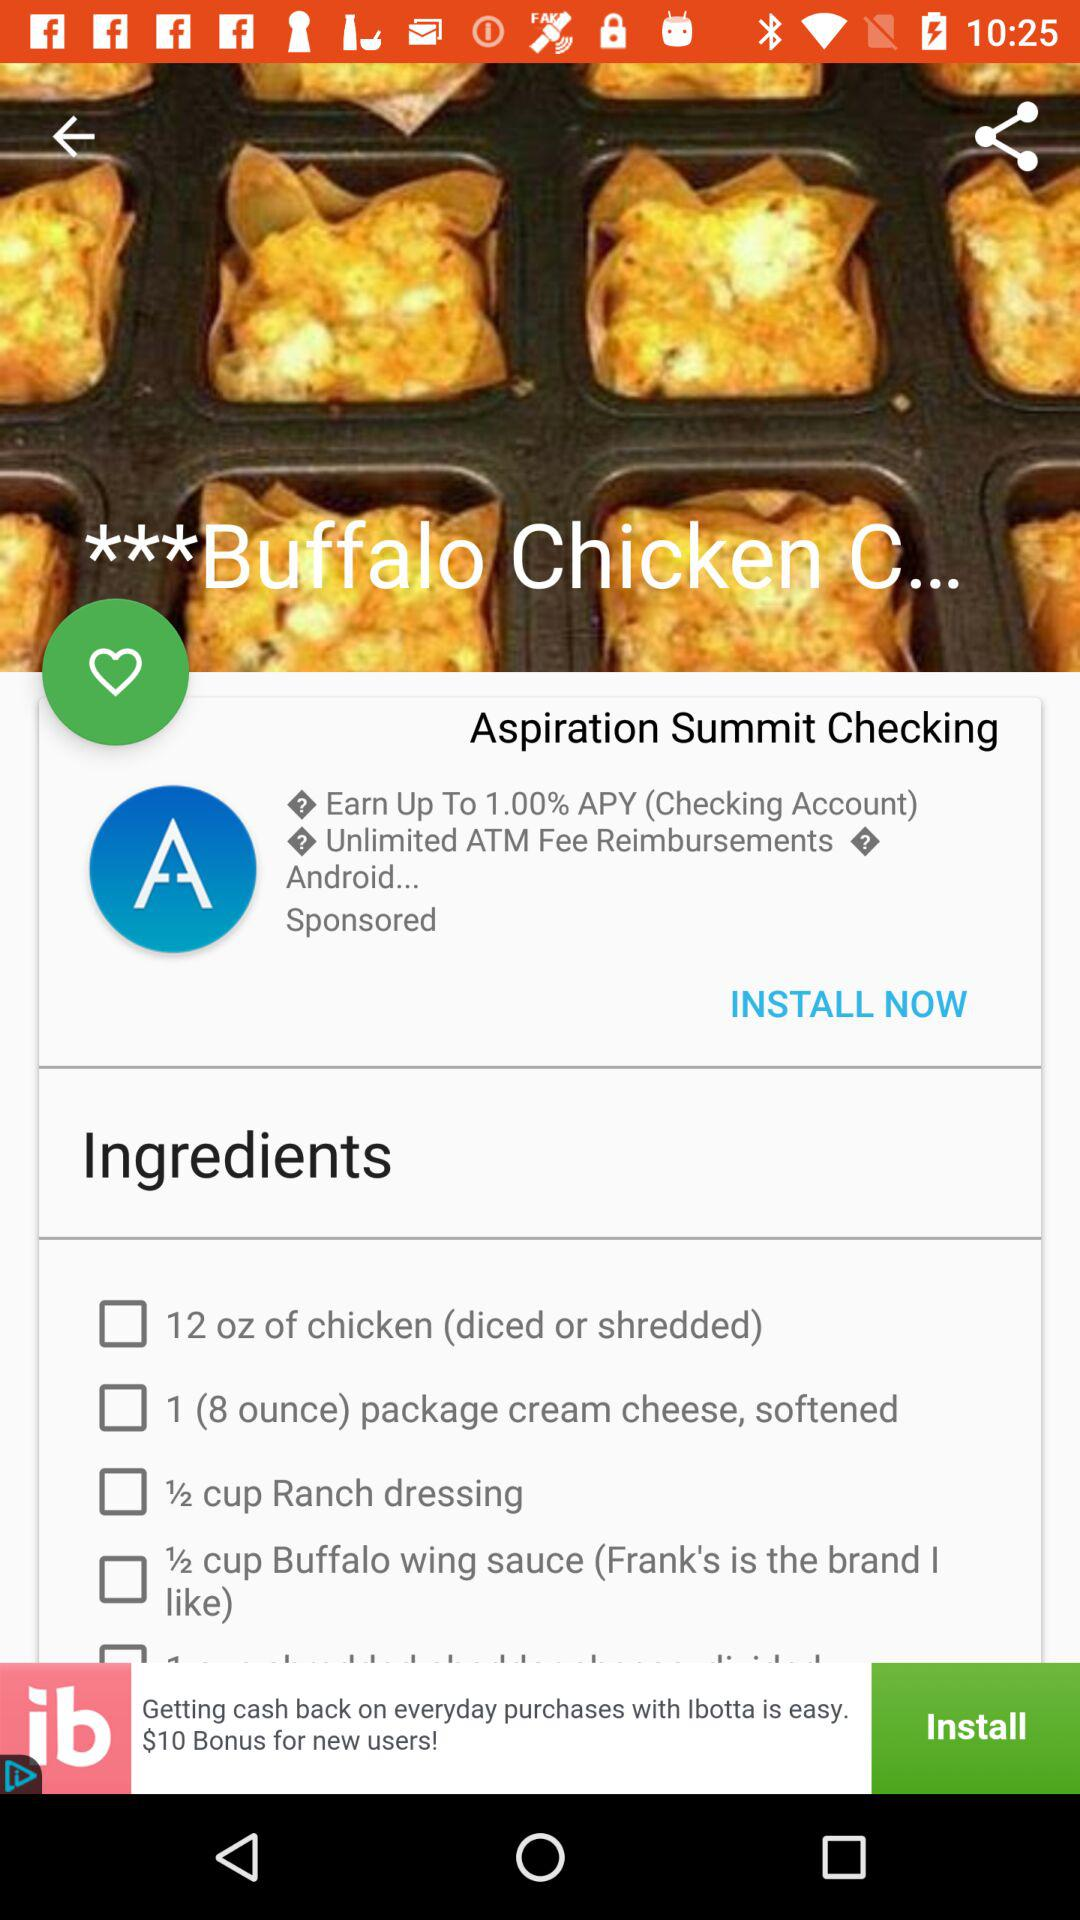How many cups of buffalo wing sauce are required to make "Buffalo Chicken"? It requires a half cup of buffalo wing sauce. 